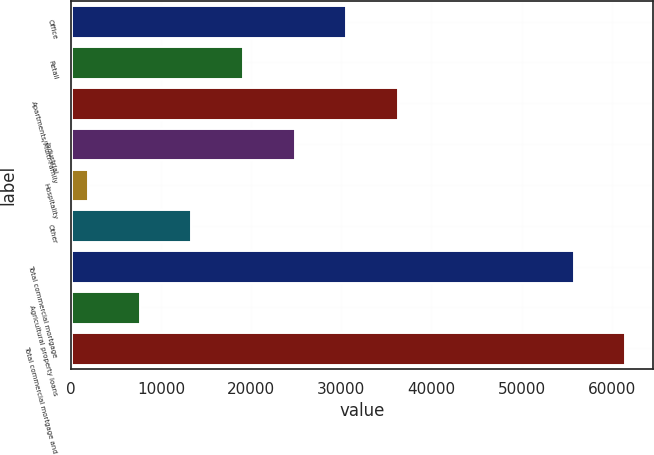<chart> <loc_0><loc_0><loc_500><loc_500><bar_chart><fcel>Office<fcel>Retail<fcel>Apartments/Multi-Family<fcel>Industrial<fcel>Hospitality<fcel>Other<fcel>Total commercial mortgage<fcel>Agricultural property loans<fcel>Total commercial mortgage and<nl><fcel>30527.5<fcel>19088.9<fcel>36246.8<fcel>24808.2<fcel>1931<fcel>13369.6<fcel>55808<fcel>7650.3<fcel>61527.3<nl></chart> 